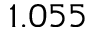<formula> <loc_0><loc_0><loc_500><loc_500>1 . 0 5 5</formula> 